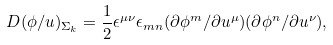Convert formula to latex. <formula><loc_0><loc_0><loc_500><loc_500>D ( \phi / u ) _ { \Sigma _ { k } } = \frac { 1 } { 2 } \epsilon ^ { \mu \nu } \epsilon _ { m n } ( \partial \phi ^ { m } / \partial { u ^ { \mu } } ) ( \partial \phi ^ { n } / \partial { u ^ { \nu } } ) ,</formula> 